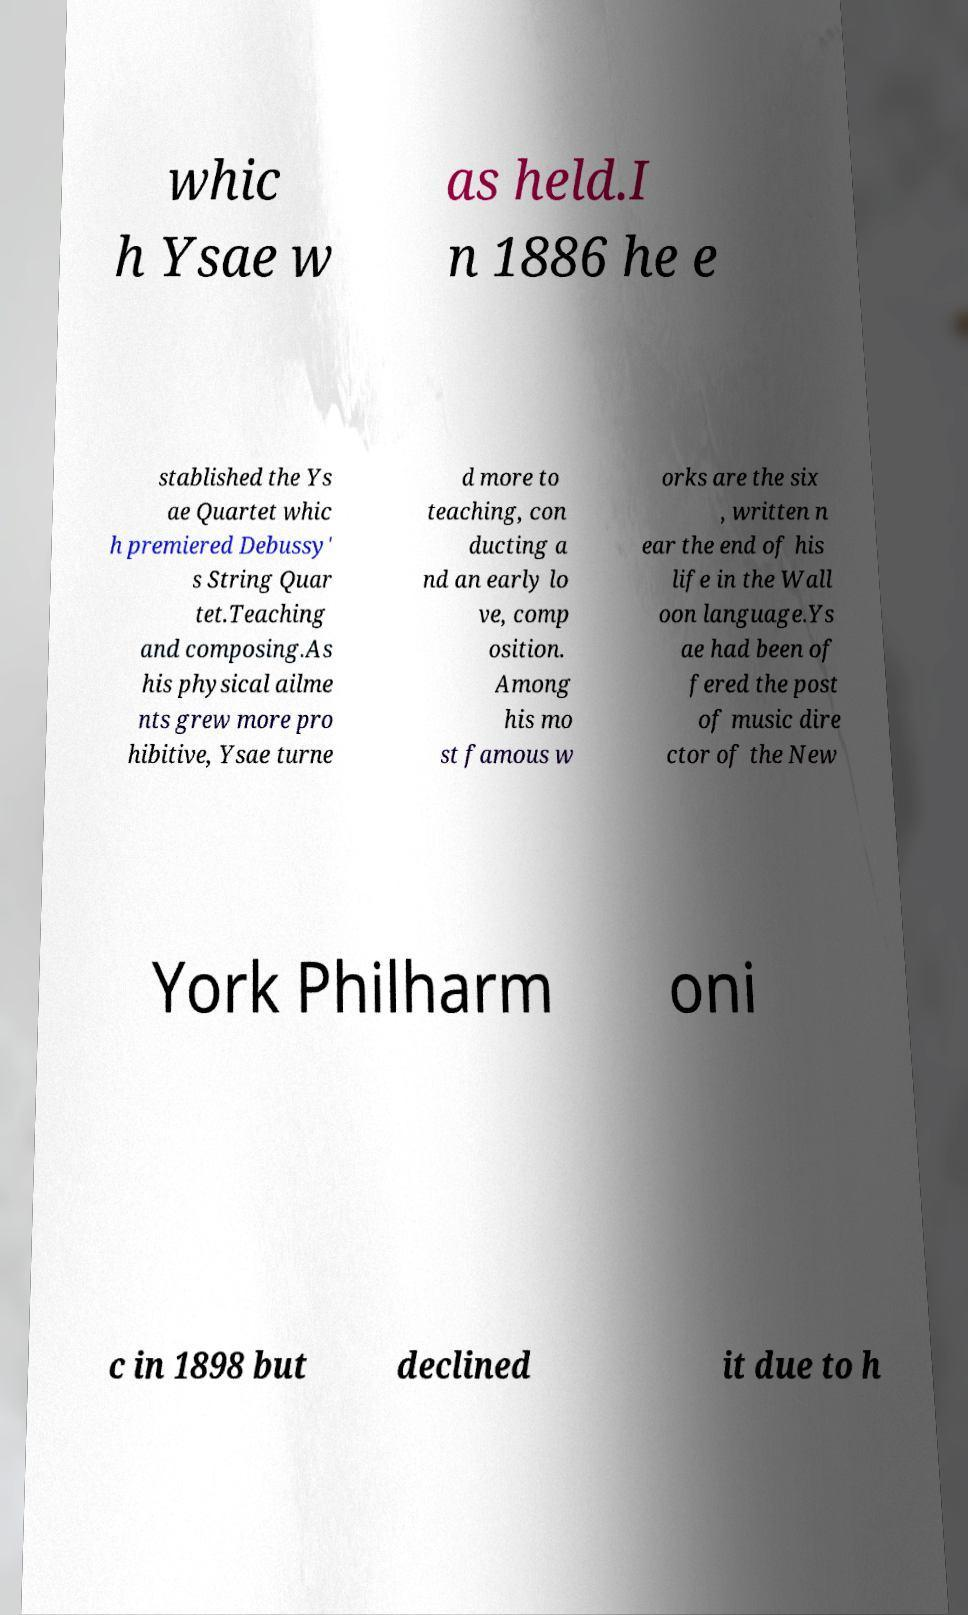I need the written content from this picture converted into text. Can you do that? whic h Ysae w as held.I n 1886 he e stablished the Ys ae Quartet whic h premiered Debussy' s String Quar tet.Teaching and composing.As his physical ailme nts grew more pro hibitive, Ysae turne d more to teaching, con ducting a nd an early lo ve, comp osition. Among his mo st famous w orks are the six , written n ear the end of his life in the Wall oon language.Ys ae had been of fered the post of music dire ctor of the New York Philharm oni c in 1898 but declined it due to h 